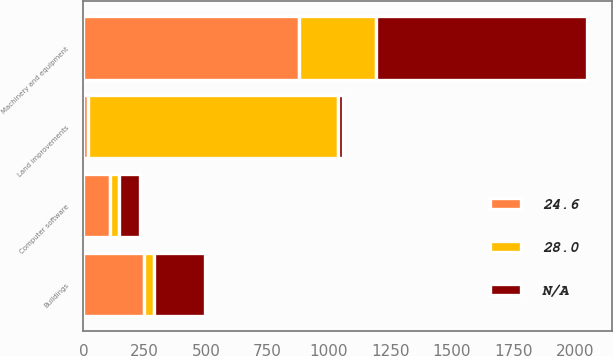<chart> <loc_0><loc_0><loc_500><loc_500><stacked_bar_chart><ecel><fcel>Land improvements<fcel>Buildings<fcel>Machinery and equipment<fcel>Computer software<nl><fcel>24.6<fcel>18<fcel>247.9<fcel>876.9<fcel>108.4<nl><fcel>nan<fcel>18.2<fcel>206.1<fcel>858.5<fcel>87.9<nl><fcel>28<fcel>1020<fcel>40<fcel>315<fcel>35<nl></chart> 